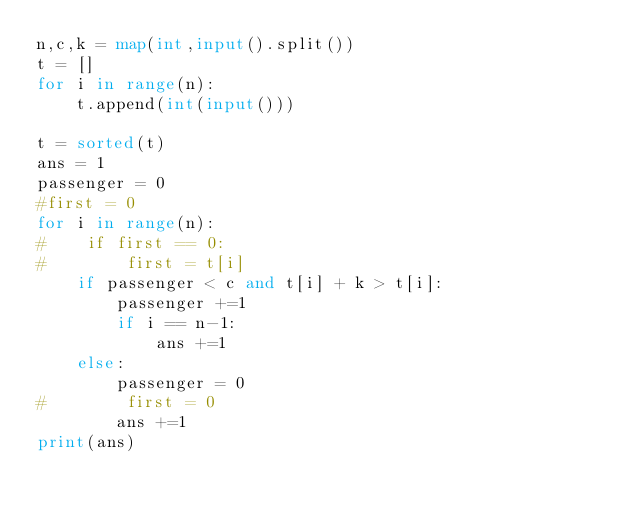<code> <loc_0><loc_0><loc_500><loc_500><_Python_>n,c,k = map(int,input().split())
t = []
for i in range(n):
    t.append(int(input()))
    
t = sorted(t)
ans = 1
passenger = 0
#first = 0
for i in range(n):
#    if first == 0:
#        first = t[i]
    if passenger < c and t[i] + k > t[i]:
        passenger +=1
        if i == n-1:
            ans +=1
    else:
        passenger = 0
#        first = 0
        ans +=1
print(ans)</code> 